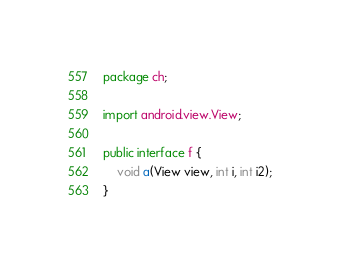Convert code to text. <code><loc_0><loc_0><loc_500><loc_500><_Java_>package ch;

import android.view.View;

public interface f {
    void a(View view, int i, int i2);
}
</code> 